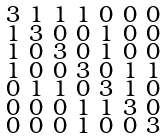<formula> <loc_0><loc_0><loc_500><loc_500>\begin{smallmatrix} 3 & 1 & 1 & 1 & 0 & 0 & 0 \\ 1 & 3 & 0 & 0 & 1 & 0 & 0 \\ 1 & 0 & 3 & 0 & 1 & 0 & 0 \\ 1 & 0 & 0 & 3 & 0 & 1 & 1 \\ 0 & 1 & 1 & 0 & 3 & 1 & 0 \\ 0 & 0 & 0 & 1 & 1 & 3 & 0 \\ 0 & 0 & 0 & 1 & 0 & 0 & 3 \end{smallmatrix}</formula> 